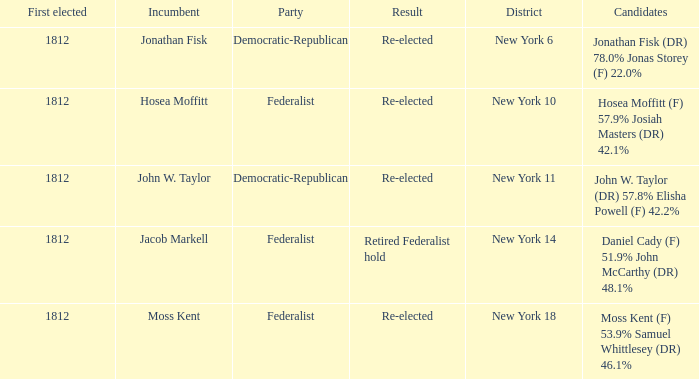Name the incumbent for new york 10 Hosea Moffitt. 